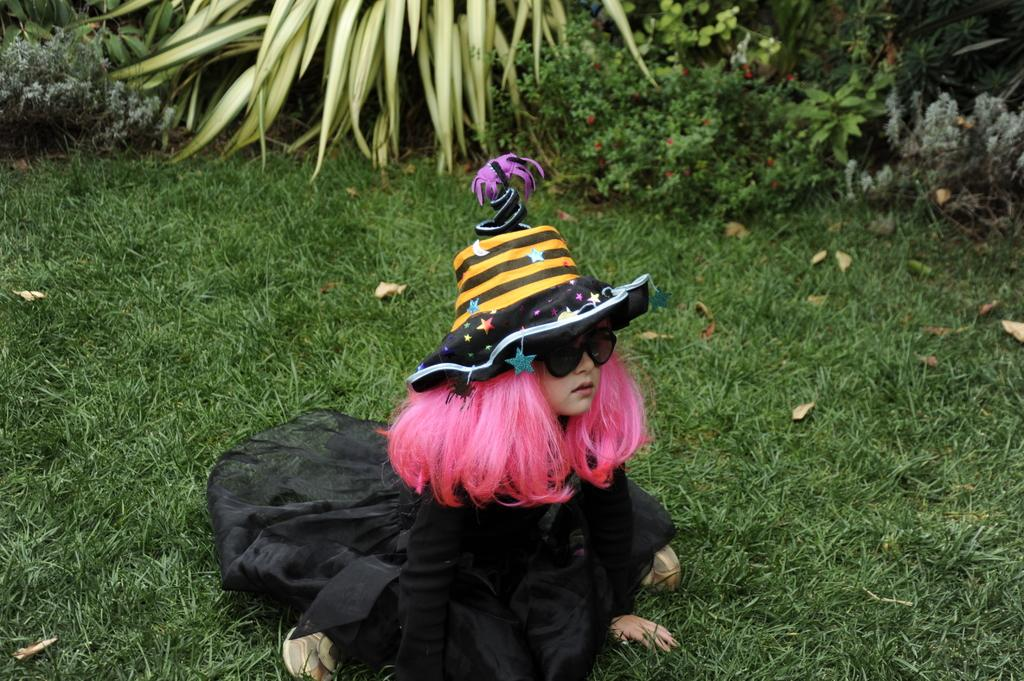Who is the main subject in the image? There is a girl in the image. Where is the girl located? The girl is on a grass field. What is the girl wearing? The girl is wearing a costume. What can be seen in the background of the image? There are plants visible in the background of the image. How many additions can be seen in the image? There are no additions present in the image; it features a girl on a grass field wearing a costume. Can you describe the nest in the image? There is no nest present in the image. 